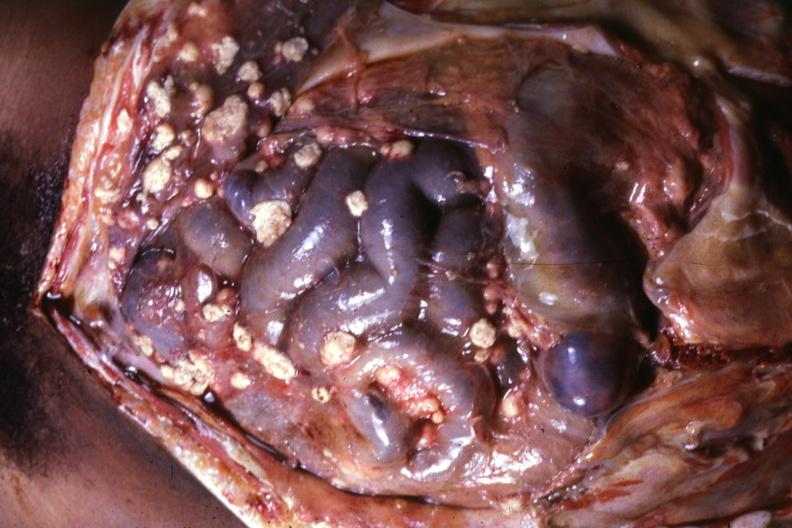s carcinomatosis present?
Answer the question using a single word or phrase. No 